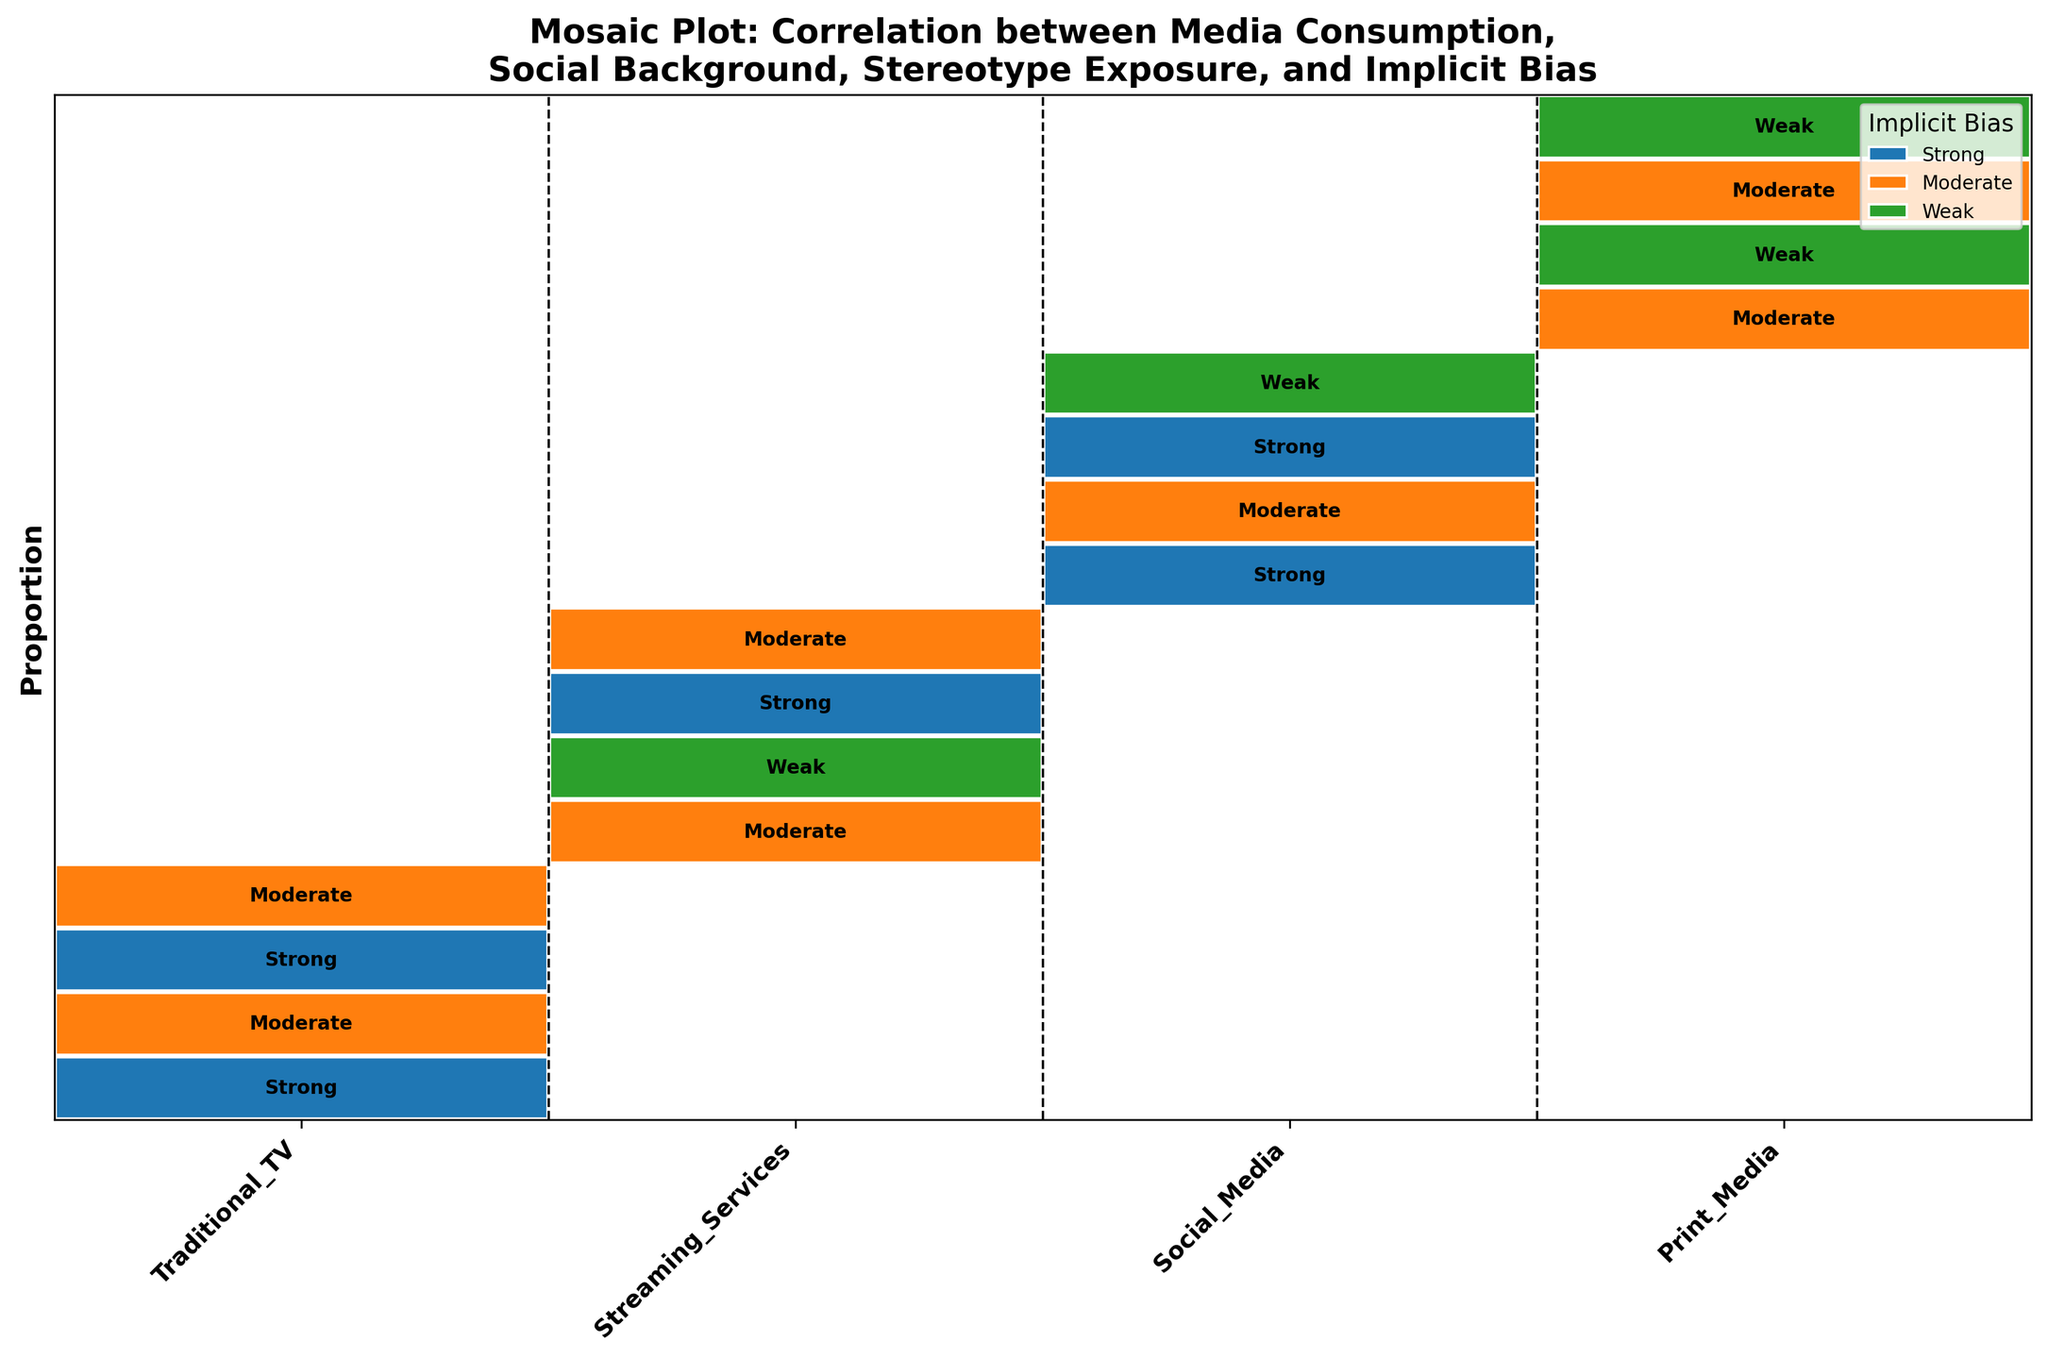What is the title of the mosaic plot? The title of the mosaic plot is generally located at the top of the figure. It is set in bold text to distinguish it.
Answer: Mosaic Plot: Correlation between Media Consumption, Social Background, Stereotype Exposure, and Implicit Bias Which media consumption category appears to have the highest proportion of strong implicit bias? To find this, look at the rectangles within each media consumption category that are colored the same as the one representing 'Strong' implicit bias (red). Look at the height of these sections.
Answer: Traditional TV and Social Media What is the implicit bias level most associated with Print Media and Urban social background? Focus on the 'Print Media' category, then locate the segment that corresponds to 'Urban'. Look at the label within the rectangle for the implicit bias level within this segment.
Answer: Moderate Compare the implicit bias levels between Urban and Rural backgrounds for Streaming Services. Which background shows a higher proportion of strong implicit bias? Find the segments under 'Streaming Services'. Compare the 'Urban' segment's height for the 'Strong' bias color with the 'Rural' segment's height for the same color.
Answer: Rural What can you infer about the exposure to stereotypical content for people with weak implicit bias? Look at all segments colored the same as the one representing 'Weak' bias and check the heights and the corresponding stereotype exposure labels within each segment.
Answer: Generally, Low exposure to stereotypical content What is the general trend regarding implicit bias in Urban areas across all media consumption categories? Look at the U-shaped segments within each media consumption category and compare their colors and heights. This helps to identify the common implicit bias level trends across all categories for Urban areas.
Answer: Mostly Moderate or Weak Analyze the implicit bias for Social Media in Rural backgrounds. Which levels are predominant? Observe the height of the rectangles under 'Social Media' categorized as 'Rural' and look for the colors that dominate these segments.
Answer: Strong How does the height of segments indicate the proportion of data points for each category? The height of each segment represents the proportion of data for that specific combination. Taller segments indicate a higher proportion of data points.
Answer: Taller segments indicate higher proportions Which media consumption category seems to have the most diversity in implicit bias levels based on segmentation height variance? Observe the variations in segment heights within each media consumption category and identify the category that displays the most variation in these heights.
Answer: Traditional TV and Streaming Services 